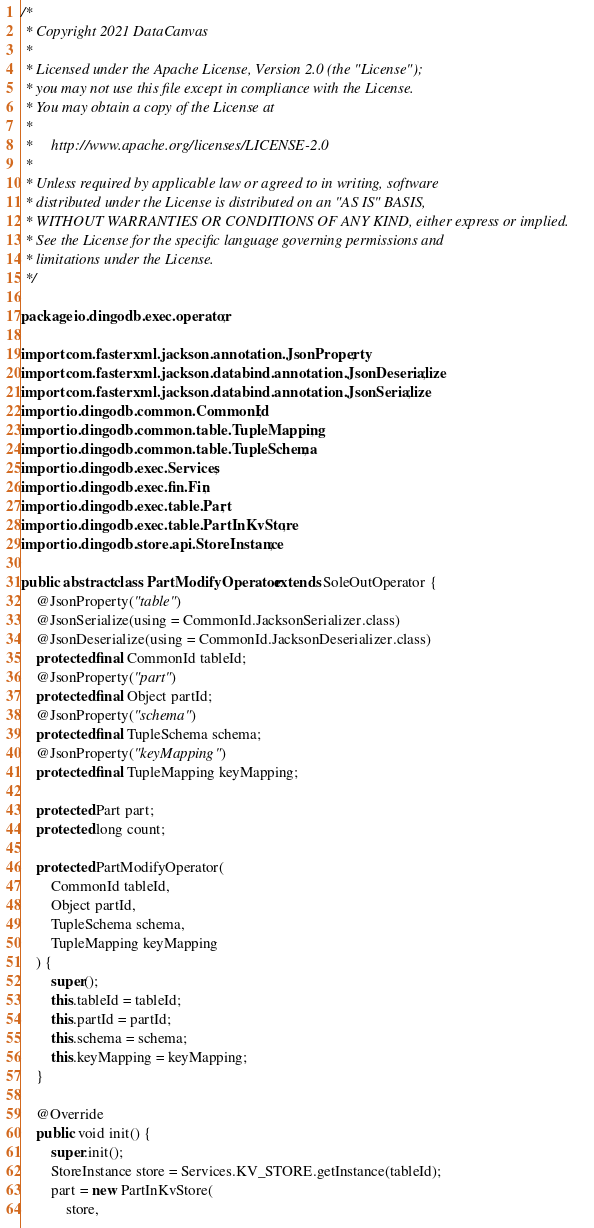<code> <loc_0><loc_0><loc_500><loc_500><_Java_>/*
 * Copyright 2021 DataCanvas
 *
 * Licensed under the Apache License, Version 2.0 (the "License");
 * you may not use this file except in compliance with the License.
 * You may obtain a copy of the License at
 *
 *     http://www.apache.org/licenses/LICENSE-2.0
 *
 * Unless required by applicable law or agreed to in writing, software
 * distributed under the License is distributed on an "AS IS" BASIS,
 * WITHOUT WARRANTIES OR CONDITIONS OF ANY KIND, either express or implied.
 * See the License for the specific language governing permissions and
 * limitations under the License.
 */

package io.dingodb.exec.operator;

import com.fasterxml.jackson.annotation.JsonProperty;
import com.fasterxml.jackson.databind.annotation.JsonDeserialize;
import com.fasterxml.jackson.databind.annotation.JsonSerialize;
import io.dingodb.common.CommonId;
import io.dingodb.common.table.TupleMapping;
import io.dingodb.common.table.TupleSchema;
import io.dingodb.exec.Services;
import io.dingodb.exec.fin.Fin;
import io.dingodb.exec.table.Part;
import io.dingodb.exec.table.PartInKvStore;
import io.dingodb.store.api.StoreInstance;

public abstract class PartModifyOperator extends SoleOutOperator {
    @JsonProperty("table")
    @JsonSerialize(using = CommonId.JacksonSerializer.class)
    @JsonDeserialize(using = CommonId.JacksonDeserializer.class)
    protected final CommonId tableId;
    @JsonProperty("part")
    protected final Object partId;
    @JsonProperty("schema")
    protected final TupleSchema schema;
    @JsonProperty("keyMapping")
    protected final TupleMapping keyMapping;

    protected Part part;
    protected long count;

    protected PartModifyOperator(
        CommonId tableId,
        Object partId,
        TupleSchema schema,
        TupleMapping keyMapping
    ) {
        super();
        this.tableId = tableId;
        this.partId = partId;
        this.schema = schema;
        this.keyMapping = keyMapping;
    }

    @Override
    public void init() {
        super.init();
        StoreInstance store = Services.KV_STORE.getInstance(tableId);
        part = new PartInKvStore(
            store,</code> 